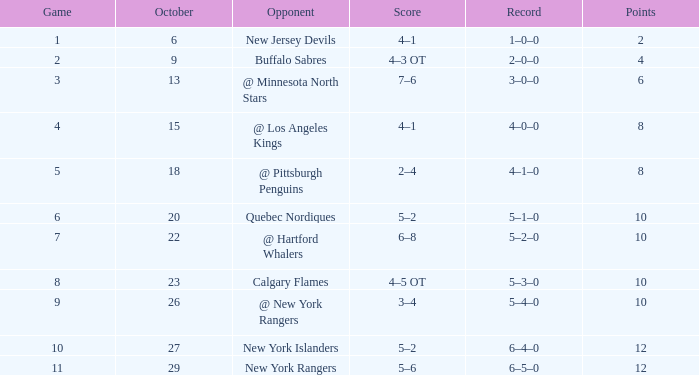How many Points have an Opponent of @ los angeles kings and a Game larger than 4? None. 